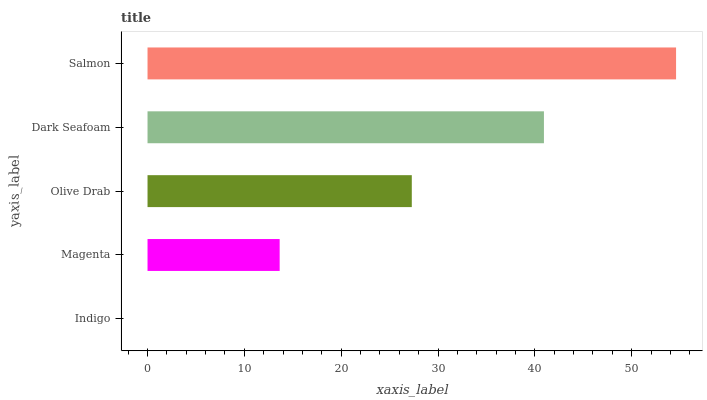Is Indigo the minimum?
Answer yes or no. Yes. Is Salmon the maximum?
Answer yes or no. Yes. Is Magenta the minimum?
Answer yes or no. No. Is Magenta the maximum?
Answer yes or no. No. Is Magenta greater than Indigo?
Answer yes or no. Yes. Is Indigo less than Magenta?
Answer yes or no. Yes. Is Indigo greater than Magenta?
Answer yes or no. No. Is Magenta less than Indigo?
Answer yes or no. No. Is Olive Drab the high median?
Answer yes or no. Yes. Is Olive Drab the low median?
Answer yes or no. Yes. Is Magenta the high median?
Answer yes or no. No. Is Magenta the low median?
Answer yes or no. No. 